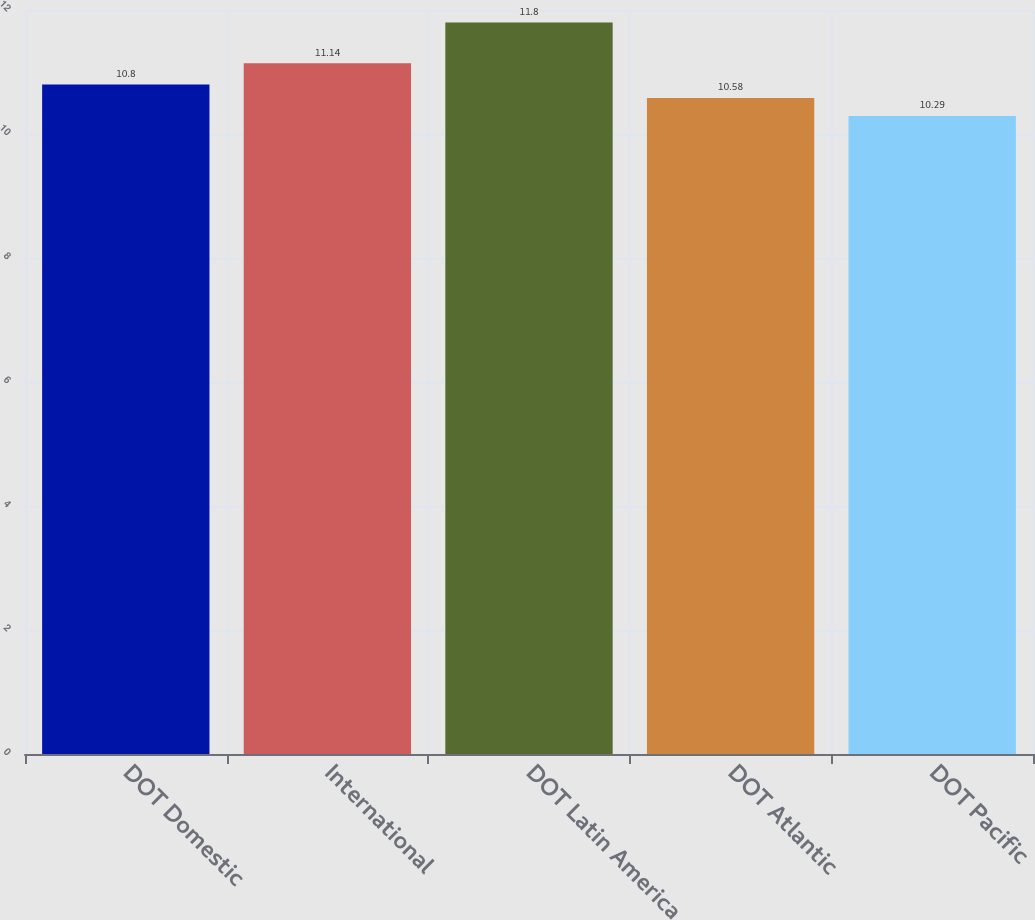<chart> <loc_0><loc_0><loc_500><loc_500><bar_chart><fcel>DOT Domestic<fcel>International<fcel>DOT Latin America<fcel>DOT Atlantic<fcel>DOT Pacific<nl><fcel>10.8<fcel>11.14<fcel>11.8<fcel>10.58<fcel>10.29<nl></chart> 